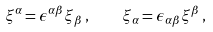<formula> <loc_0><loc_0><loc_500><loc_500>\xi ^ { \alpha } = \epsilon ^ { \alpha \beta } \xi _ { \beta } \, , \quad \xi _ { \alpha } = \epsilon _ { \alpha \beta } \xi ^ { \beta } \, ,</formula> 